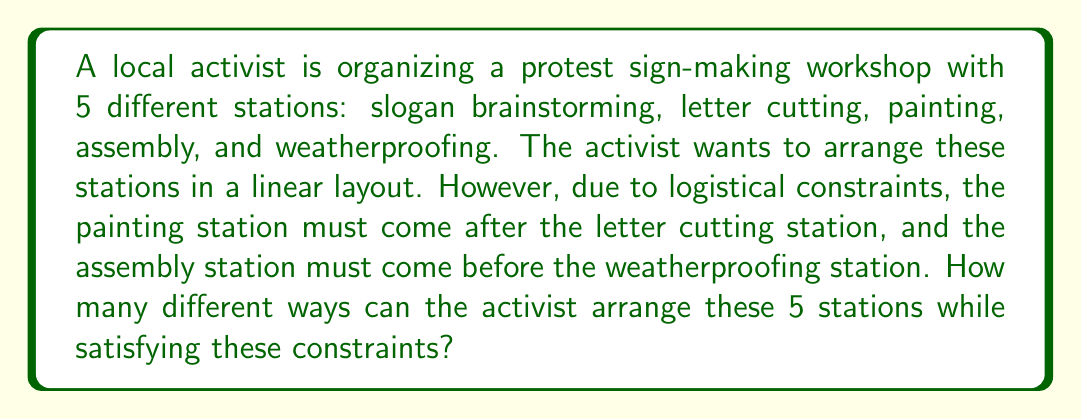Can you solve this math problem? Let's approach this step-by-step:

1) First, we need to consider the constraints:
   - Painting must come after letter cutting
   - Assembly must come before weatherproofing

2) Given these constraints, we can think of the letter cutting and painting stations as one unit, and the assembly and weatherproofing stations as another unit.

3) So, we effectively have 4 elements to arrange:
   - Slogan brainstorming (S)
   - Letter cutting + Painting (LP)
   - Assembly + Weatherproofing (AW)
   - The remaining station from LP or AW

4) We can arrange these 4 elements in 4! = 24 ways.

5) However, for each of these 24 arrangements, we need to consider the internal arrangement of LP and AW:
   - For LP: Letter cutting must come before Painting (only 1 way)
   - For AW: Assembly must come before Weatherproofing (only 1 way)

6) Therefore, the total number of arrangements is:

   $$ 24 \times 1 \times 1 = 24 $$

Thus, there are 24 different ways to arrange the stations while satisfying the given constraints.
Answer: 24 ways 